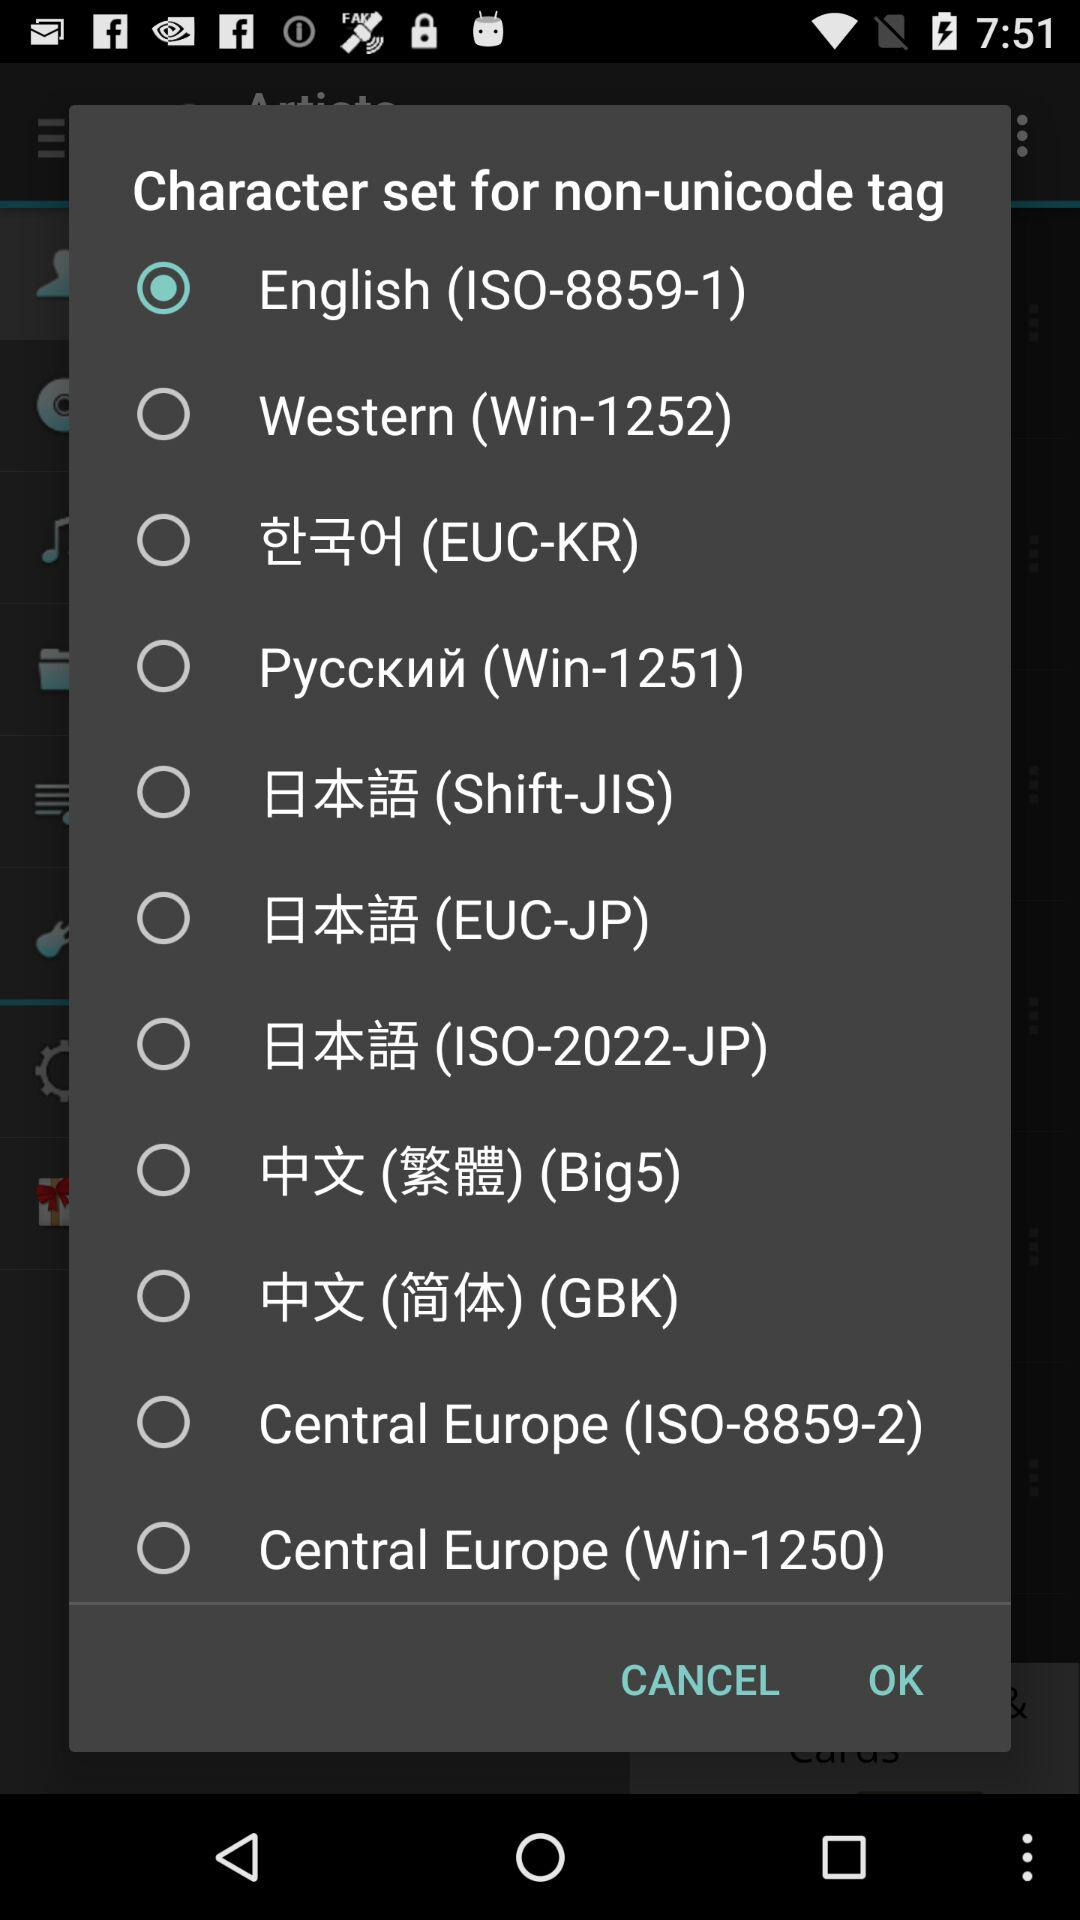Which option is selected? The selected option is "English (ISO-8859-1)". 